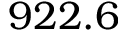Convert formula to latex. <formula><loc_0><loc_0><loc_500><loc_500>9 2 2 . 6</formula> 